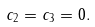Convert formula to latex. <formula><loc_0><loc_0><loc_500><loc_500>c _ { 2 } = c _ { 3 } = 0 .</formula> 